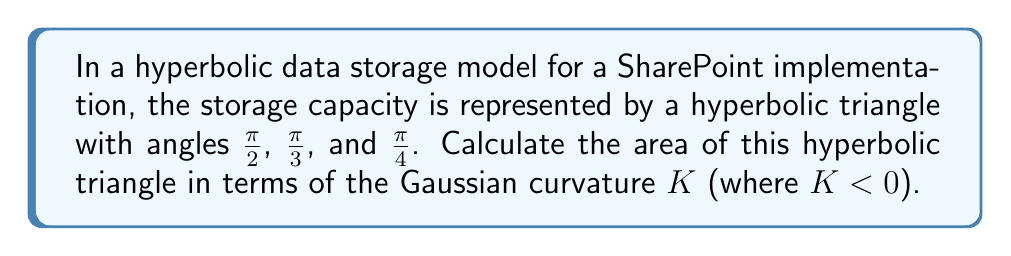Can you answer this question? To solve this problem, we'll use the Gauss-Bonnet theorem for hyperbolic geometry:

1) The Gauss-Bonnet theorem for a hyperbolic triangle states:

   $$A = \frac{\pi - (\alpha + \beta + \gamma)}{-K}$$

   where $A$ is the area, $K$ is the Gaussian curvature (negative in hyperbolic space), and $\alpha$, $\beta$, $\gamma$ are the angles of the triangle.

2) We're given the angles: $\alpha = \frac{\pi}{2}$, $\beta = \frac{\pi}{3}$, $\gamma = \frac{\pi}{4}$

3) Let's substitute these into the formula:

   $$A = \frac{\pi - (\frac{\pi}{2} + \frac{\pi}{3} + \frac{\pi}{4})}{-K}$$

4) Simplify the numerator:
   
   $$A = \frac{\pi - (\frac{6\pi}{12} + \frac{4\pi}{12} + \frac{3\pi}{12})}{-K} = \frac{\pi - \frac{13\pi}{12}}{-K}$$

5) Further simplification:

   $$A = \frac{\frac{12\pi}{12} - \frac{13\pi}{12}}{-K} = \frac{-\frac{\pi}{12}}{-K} = \frac{\pi}{12K}$$

Thus, the area of the hyperbolic triangle representing the SharePoint data storage capacity is $\frac{\pi}{12K}$.
Answer: $\frac{\pi}{12K}$ 